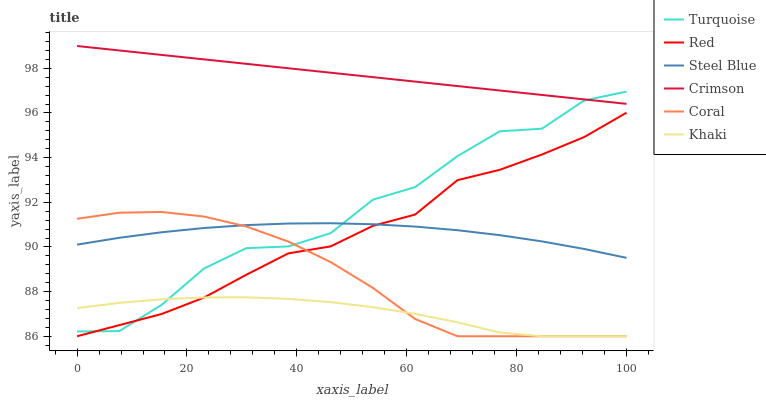Does Khaki have the minimum area under the curve?
Answer yes or no. Yes. Does Crimson have the maximum area under the curve?
Answer yes or no. Yes. Does Coral have the minimum area under the curve?
Answer yes or no. No. Does Coral have the maximum area under the curve?
Answer yes or no. No. Is Crimson the smoothest?
Answer yes or no. Yes. Is Turquoise the roughest?
Answer yes or no. Yes. Is Khaki the smoothest?
Answer yes or no. No. Is Khaki the roughest?
Answer yes or no. No. Does Khaki have the lowest value?
Answer yes or no. Yes. Does Steel Blue have the lowest value?
Answer yes or no. No. Does Crimson have the highest value?
Answer yes or no. Yes. Does Coral have the highest value?
Answer yes or no. No. Is Khaki less than Steel Blue?
Answer yes or no. Yes. Is Crimson greater than Khaki?
Answer yes or no. Yes. Does Coral intersect Turquoise?
Answer yes or no. Yes. Is Coral less than Turquoise?
Answer yes or no. No. Is Coral greater than Turquoise?
Answer yes or no. No. Does Khaki intersect Steel Blue?
Answer yes or no. No. 